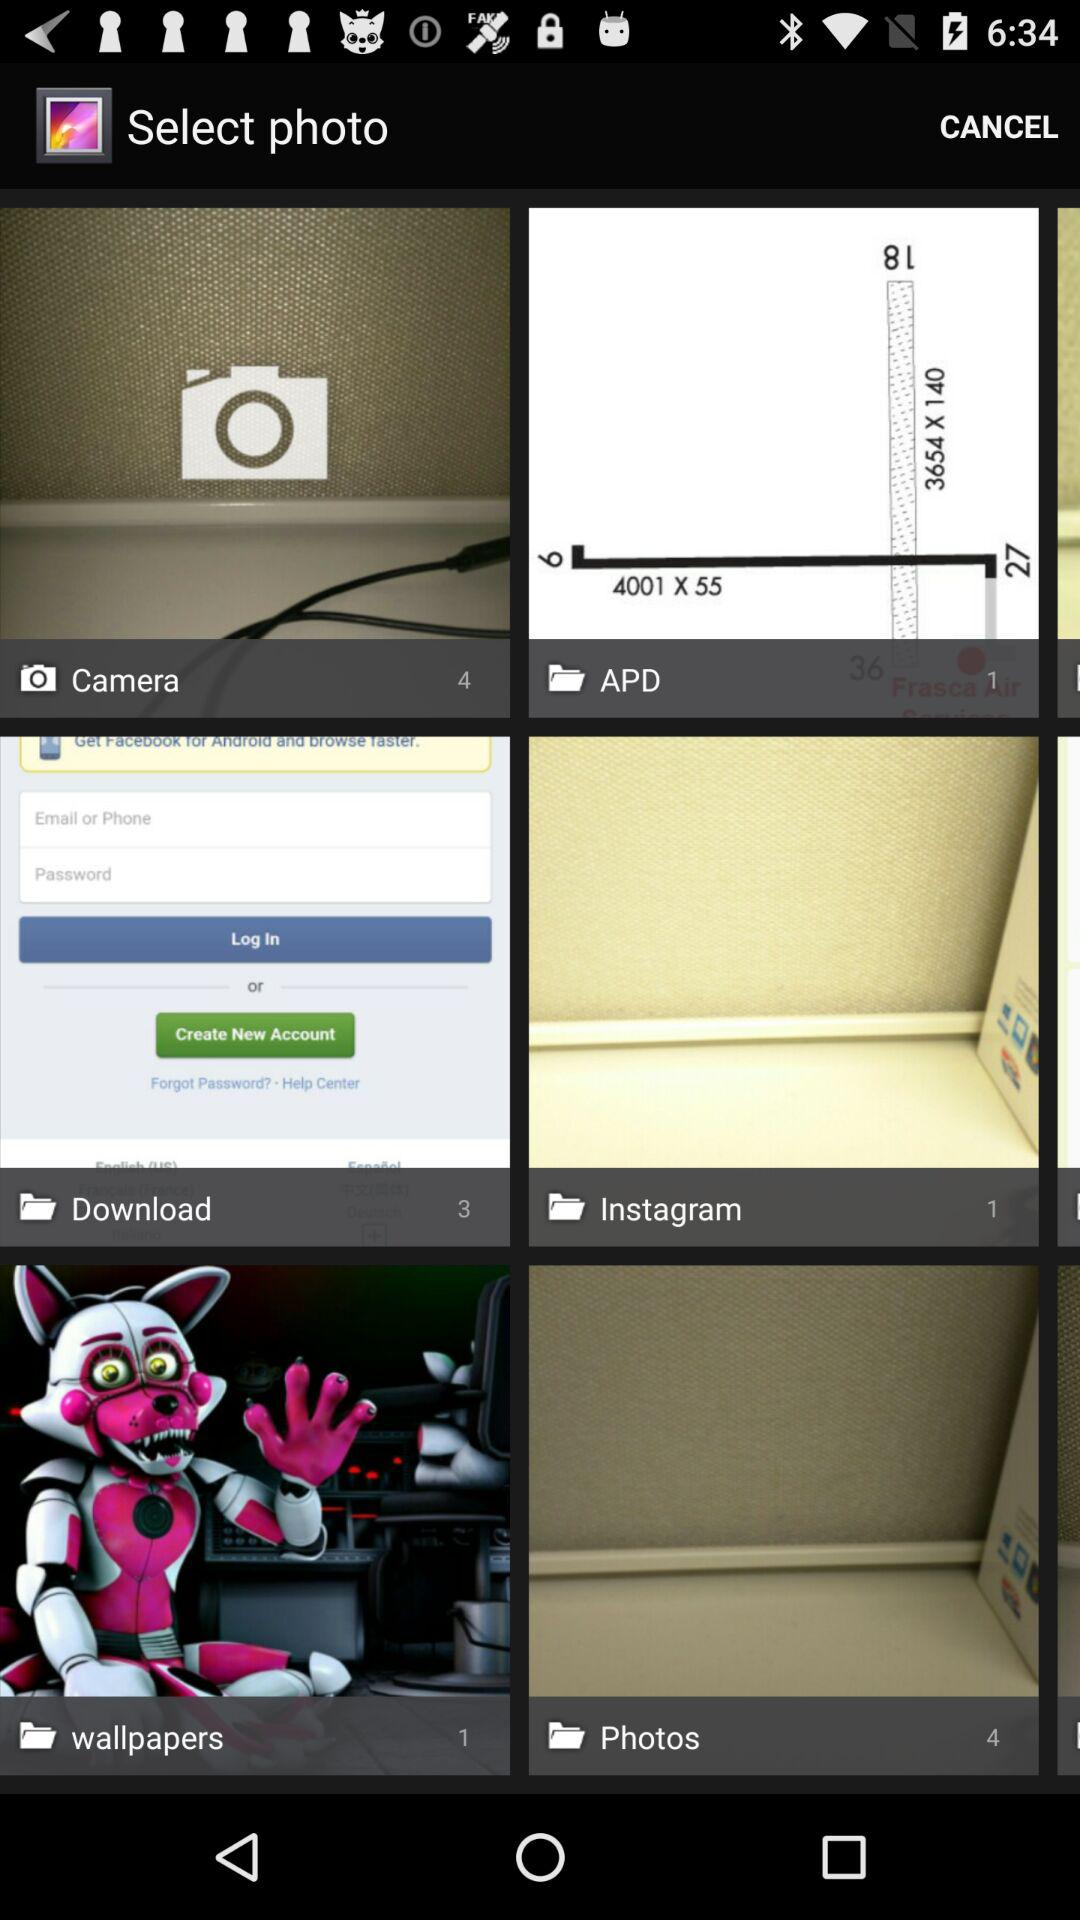How many images are in the "Download" folder? There are 3 images in the "Download" folder. 